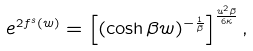<formula> <loc_0><loc_0><loc_500><loc_500>e ^ { 2 f ^ { s } ( w ) } = \left [ ( \cosh \beta w ) ^ { - \frac { 1 } { \beta } } \right ] ^ { \frac { u ^ { 2 } \beta } { 6 \kappa } } ,</formula> 